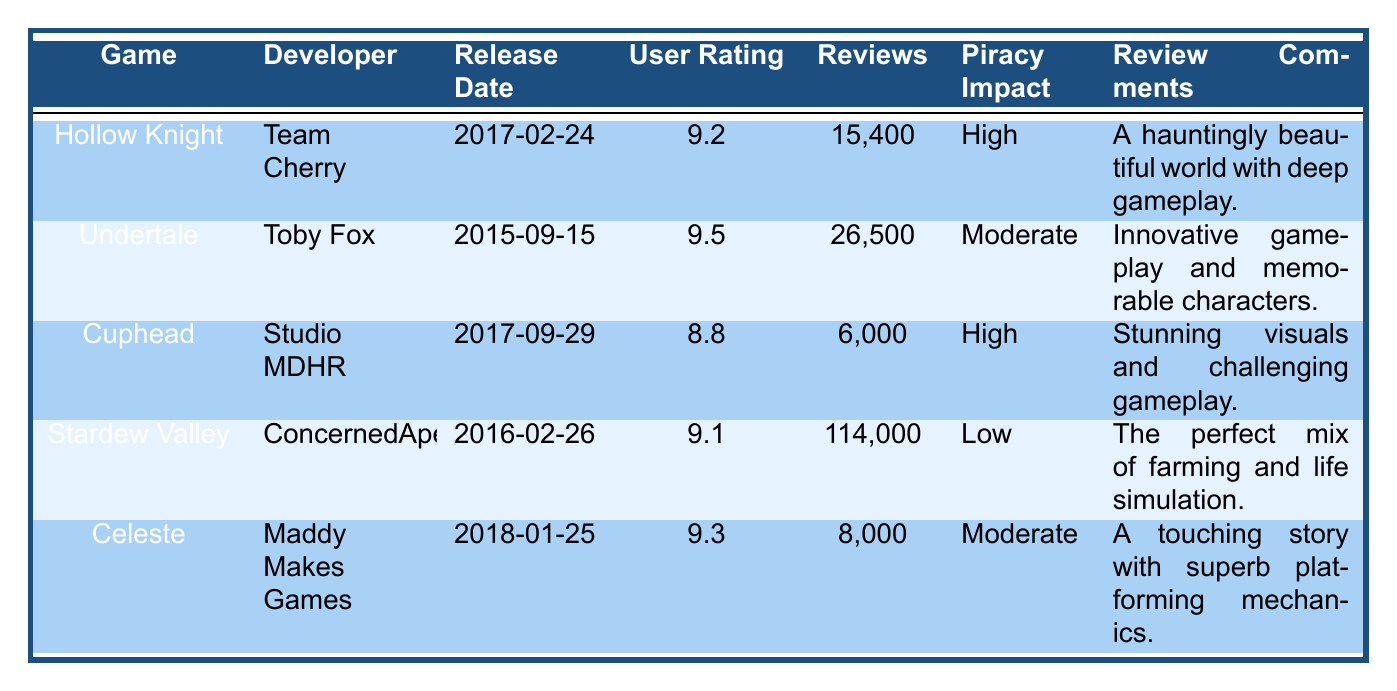What is the user rating for Hollow Knight? The user rating for Hollow Knight can be found directly in the table. It is listed under the "User Rating" column next to the game title. The value shows that the rating is 9.2.
Answer: 9.2 How many reviews does Stardew Valley have? The number of reviews for Stardew Valley is explicitly stated in the "Reviews" column of the table. It indicates that there are 114,000 reviews for the game.
Answer: 114,000 Is Cuphead estimated to have high piracy impact? The table specifies the estimated piracy impact for Cuphead in the "Piracy Impact" column. It states "High" next to Cuphead, confirming the impact estimation is indeed high.
Answer: Yes What is the average user rating of games with high piracy impact? We first identify the games with high piracy impact, which are Hollow Knight and Cuphead, with ratings of 9.2 and 8.8 respectively. Then, we calculate the average user rating: (9.2 + 8.8) / 2 = 9.0. Thus, the average user rating is 9.0.
Answer: 9.0 How many total reviews do games with moderate piracy impact have? The games with moderate piracy impact are Undertale and Celeste. Their reviews count is 26,500 for Undertale and 8,000 for Celeste. We sum these values: 26,500 + 8,000 = 34,500. Therefore, the total reviews from these games is 34,500.
Answer: 34,500 Which game has the lowest user rating? To find the game with the lowest user rating, we compare all listed user ratings from the table. The ratings are 9.2, 9.5, 8.8, 9.1, and 9.3, with 8.8 being the lowest. It corresponds to Cuphead.
Answer: Cuphead Does Stardew Valley have a moderate piracy impact estimation? Referring to the table, we check the piracy impact estimation for Stardew Valley located in the "Piracy Impact" column. It is stated as "Low," hence the answer to whether it has a moderate impact is no.
Answer: No What is the difference in the number of reviews between Undertale and Hollow Knight? We look up the number of reviews in the "Reviews" column for both games: Undertale has 26,500 reviews and Hollow Knight has 15,400 reviews. The difference is calculated as 26,500 - 15,400 = 11,100.
Answer: 11,100 